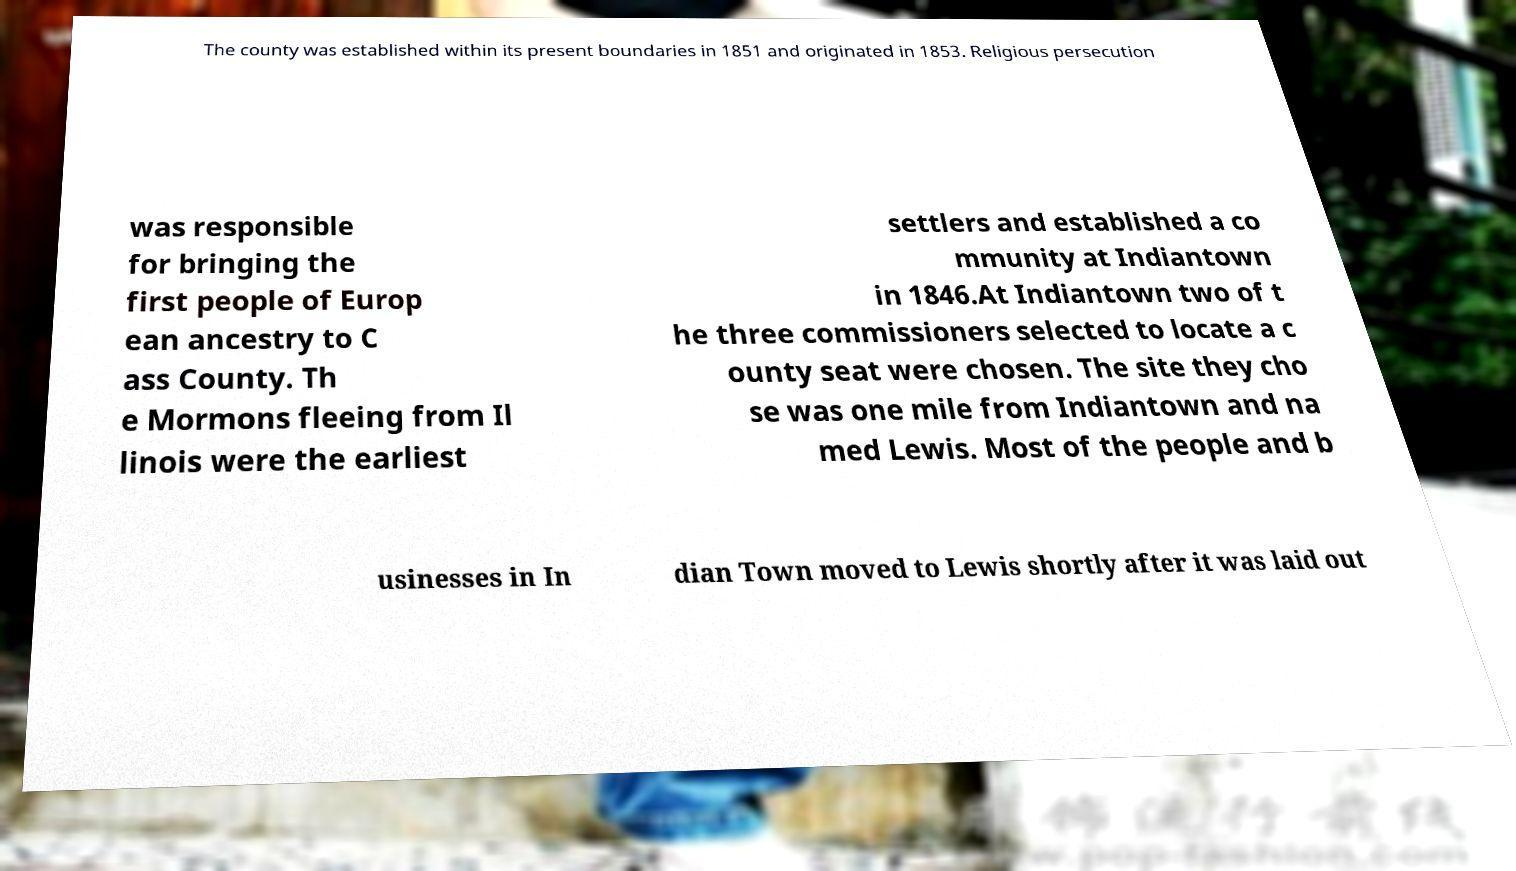Can you accurately transcribe the text from the provided image for me? The county was established within its present boundaries in 1851 and originated in 1853. Religious persecution was responsible for bringing the first people of Europ ean ancestry to C ass County. Th e Mormons fleeing from Il linois were the earliest settlers and established a co mmunity at Indiantown in 1846.At Indiantown two of t he three commissioners selected to locate a c ounty seat were chosen. The site they cho se was one mile from Indiantown and na med Lewis. Most of the people and b usinesses in In dian Town moved to Lewis shortly after it was laid out 